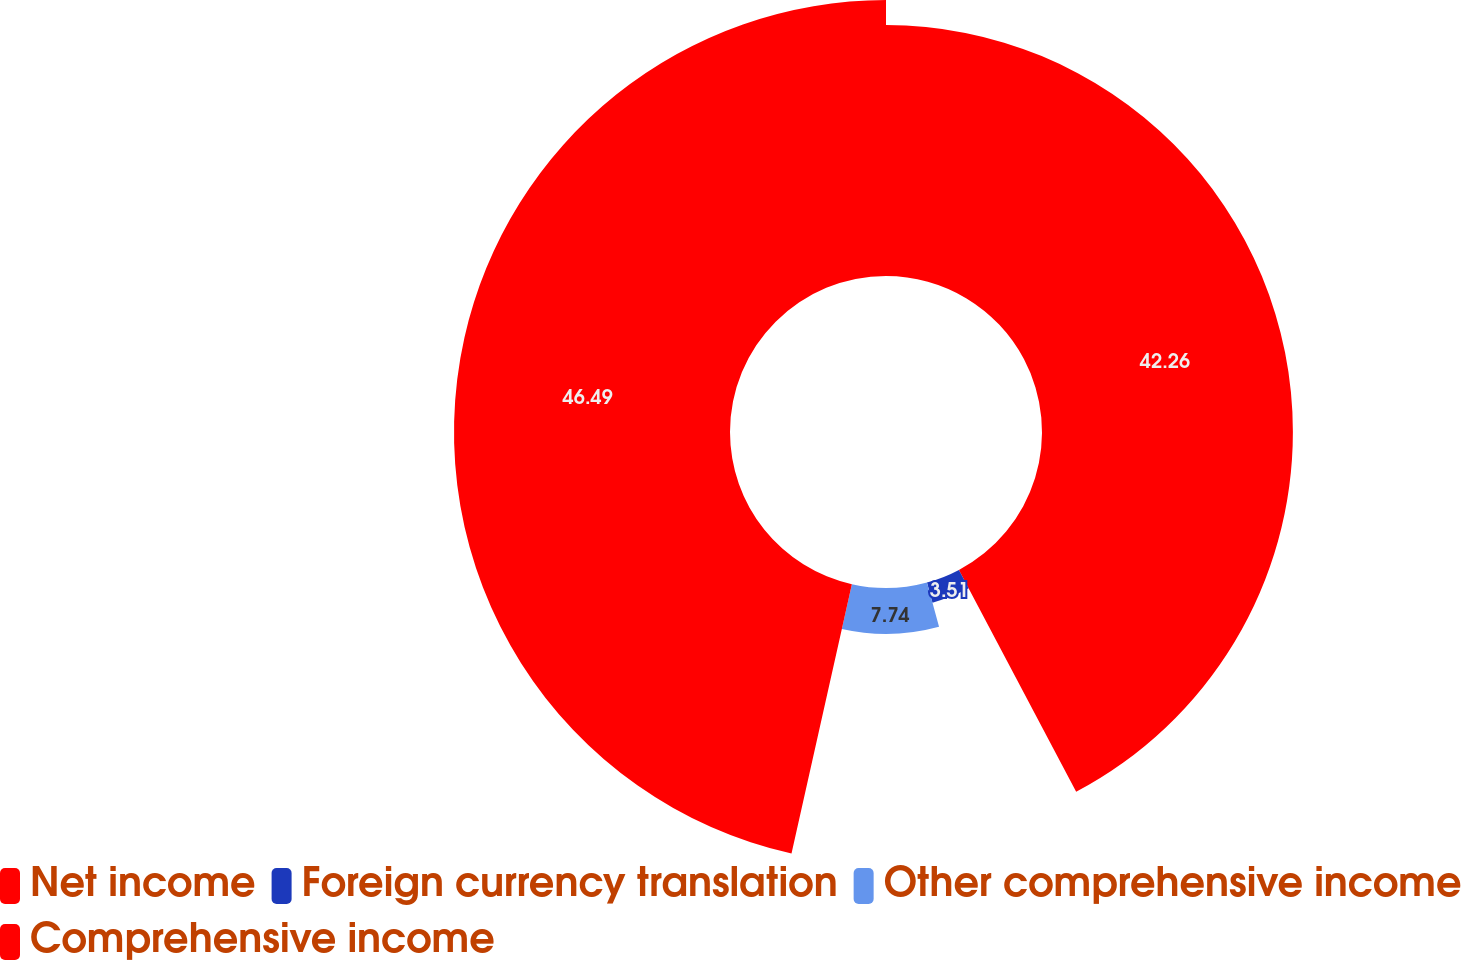Convert chart to OTSL. <chart><loc_0><loc_0><loc_500><loc_500><pie_chart><fcel>Net income<fcel>Foreign currency translation<fcel>Other comprehensive income<fcel>Comprehensive income<nl><fcel>42.26%<fcel>3.51%<fcel>7.74%<fcel>46.49%<nl></chart> 